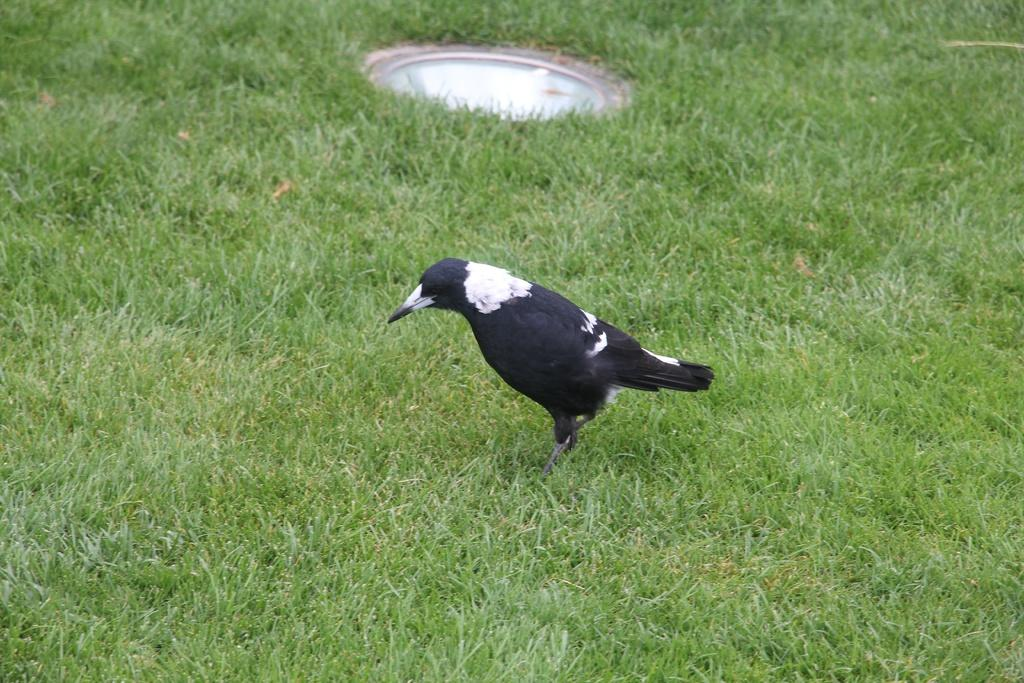What type of animal can be seen in the image? There is a black bird in the image. What is visible beneath the bird? The ground is visible in the image. What type of vegetation is present on the ground? Grass is present on the ground. What force is being exerted by the bird in the image? There is no indication of any force being exerted by the bird in the image. 